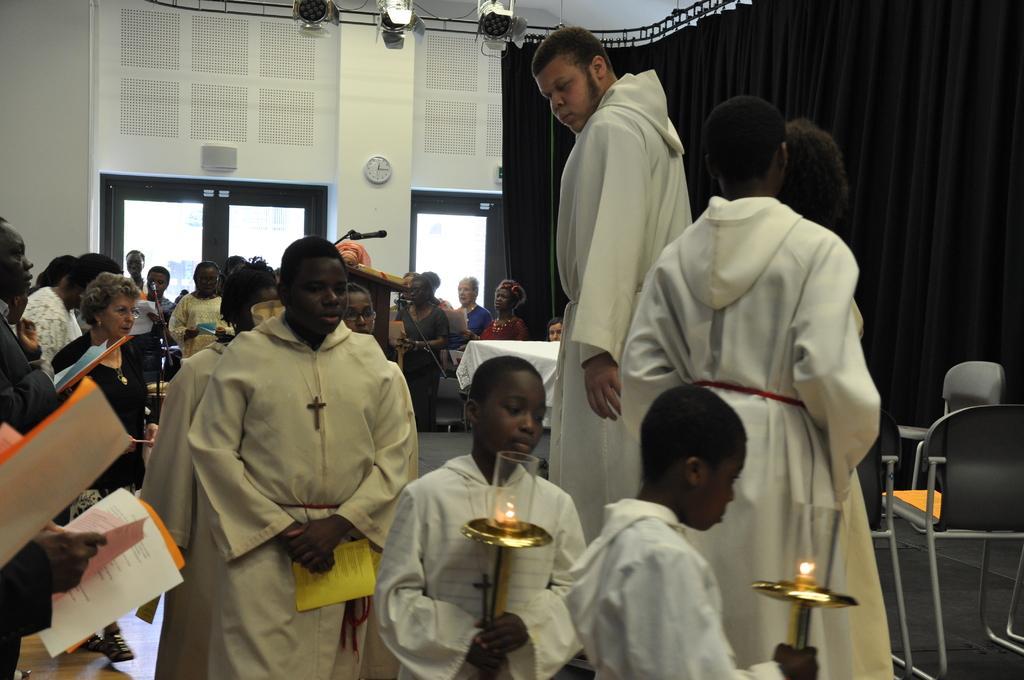Could you give a brief overview of what you see in this image? In the foreground of the image there are two kids wearing white color dress holding candles in their hands. In the background of the image there are people. There is wall. There are windows. There is a clock on the wall. To the right side of the image there is a black color curtain. There are chairs. 